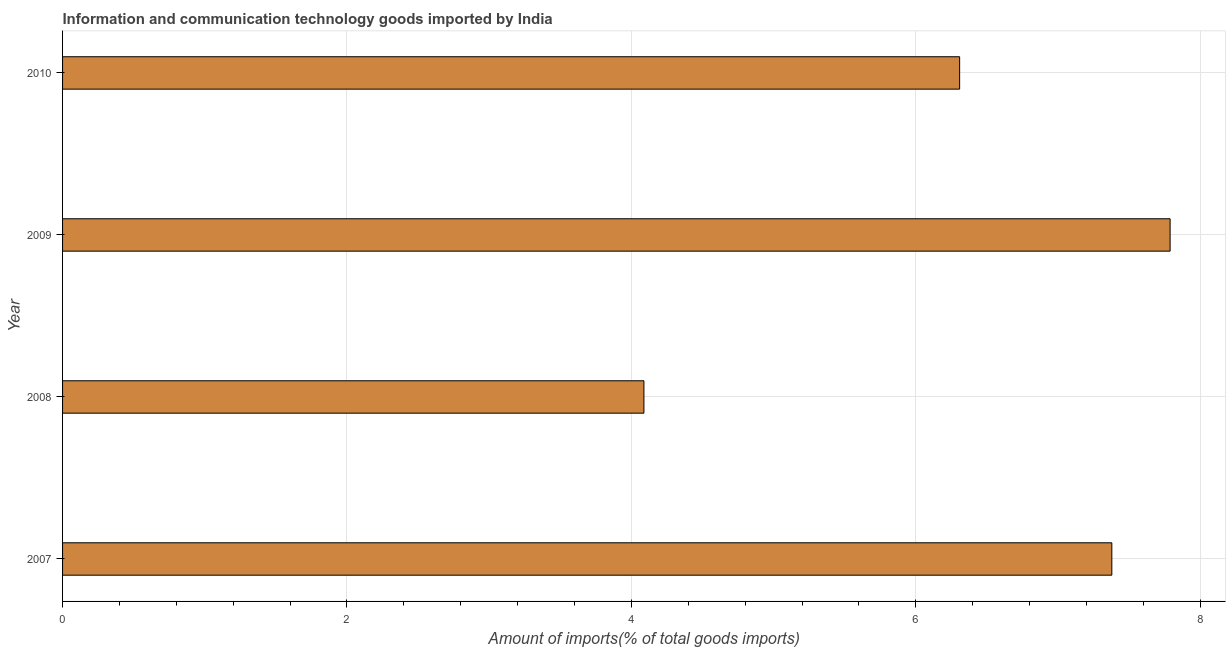Does the graph contain any zero values?
Give a very brief answer. No. What is the title of the graph?
Ensure brevity in your answer.  Information and communication technology goods imported by India. What is the label or title of the X-axis?
Your answer should be very brief. Amount of imports(% of total goods imports). What is the label or title of the Y-axis?
Your answer should be compact. Year. What is the amount of ict goods imports in 2010?
Offer a very short reply. 6.31. Across all years, what is the maximum amount of ict goods imports?
Ensure brevity in your answer.  7.79. Across all years, what is the minimum amount of ict goods imports?
Make the answer very short. 4.09. What is the sum of the amount of ict goods imports?
Give a very brief answer. 25.56. What is the difference between the amount of ict goods imports in 2007 and 2008?
Give a very brief answer. 3.29. What is the average amount of ict goods imports per year?
Your answer should be compact. 6.39. What is the median amount of ict goods imports?
Provide a succinct answer. 6.84. Do a majority of the years between 2008 and 2007 (inclusive) have amount of ict goods imports greater than 0.4 %?
Provide a short and direct response. No. What is the ratio of the amount of ict goods imports in 2007 to that in 2010?
Your response must be concise. 1.17. What is the difference between the highest and the second highest amount of ict goods imports?
Ensure brevity in your answer.  0.41. Is the sum of the amount of ict goods imports in 2008 and 2009 greater than the maximum amount of ict goods imports across all years?
Give a very brief answer. Yes. What is the difference between the highest and the lowest amount of ict goods imports?
Ensure brevity in your answer.  3.7. How many bars are there?
Your answer should be compact. 4. Are all the bars in the graph horizontal?
Make the answer very short. Yes. What is the Amount of imports(% of total goods imports) of 2007?
Make the answer very short. 7.38. What is the Amount of imports(% of total goods imports) in 2008?
Offer a very short reply. 4.09. What is the Amount of imports(% of total goods imports) of 2009?
Give a very brief answer. 7.79. What is the Amount of imports(% of total goods imports) in 2010?
Provide a succinct answer. 6.31. What is the difference between the Amount of imports(% of total goods imports) in 2007 and 2008?
Your response must be concise. 3.29. What is the difference between the Amount of imports(% of total goods imports) in 2007 and 2009?
Keep it short and to the point. -0.41. What is the difference between the Amount of imports(% of total goods imports) in 2007 and 2010?
Offer a very short reply. 1.07. What is the difference between the Amount of imports(% of total goods imports) in 2008 and 2009?
Ensure brevity in your answer.  -3.7. What is the difference between the Amount of imports(% of total goods imports) in 2008 and 2010?
Keep it short and to the point. -2.22. What is the difference between the Amount of imports(% of total goods imports) in 2009 and 2010?
Provide a short and direct response. 1.48. What is the ratio of the Amount of imports(% of total goods imports) in 2007 to that in 2008?
Provide a succinct answer. 1.8. What is the ratio of the Amount of imports(% of total goods imports) in 2007 to that in 2009?
Give a very brief answer. 0.95. What is the ratio of the Amount of imports(% of total goods imports) in 2007 to that in 2010?
Offer a very short reply. 1.17. What is the ratio of the Amount of imports(% of total goods imports) in 2008 to that in 2009?
Your response must be concise. 0.53. What is the ratio of the Amount of imports(% of total goods imports) in 2008 to that in 2010?
Offer a terse response. 0.65. What is the ratio of the Amount of imports(% of total goods imports) in 2009 to that in 2010?
Provide a succinct answer. 1.24. 